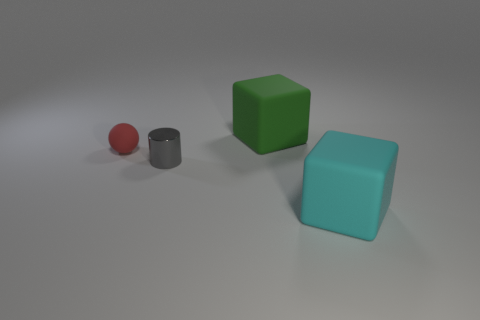Add 4 large red balls. How many objects exist? 8 Subtract all spheres. How many objects are left? 3 Subtract 0 red blocks. How many objects are left? 4 Subtract all tiny gray metal objects. Subtract all gray shiny objects. How many objects are left? 2 Add 1 small matte spheres. How many small matte spheres are left? 2 Add 2 metal objects. How many metal objects exist? 3 